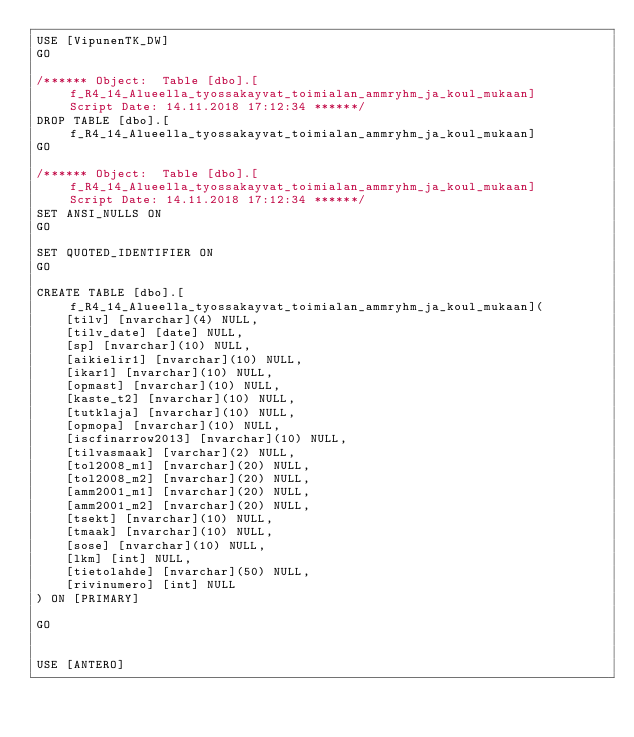<code> <loc_0><loc_0><loc_500><loc_500><_SQL_>USE [VipunenTK_DW]
GO

/****** Object:  Table [dbo].[f_R4_14_Alueella_tyossakayvat_toimialan_ammryhm_ja_koul_mukaan]    Script Date: 14.11.2018 17:12:34 ******/
DROP TABLE [dbo].[f_R4_14_Alueella_tyossakayvat_toimialan_ammryhm_ja_koul_mukaan]
GO

/****** Object:  Table [dbo].[f_R4_14_Alueella_tyossakayvat_toimialan_ammryhm_ja_koul_mukaan]    Script Date: 14.11.2018 17:12:34 ******/
SET ANSI_NULLS ON
GO

SET QUOTED_IDENTIFIER ON
GO

CREATE TABLE [dbo].[f_R4_14_Alueella_tyossakayvat_toimialan_ammryhm_ja_koul_mukaan](
	[tilv] [nvarchar](4) NULL,
	[tilv_date] [date] NULL,
	[sp] [nvarchar](10) NULL,
	[aikielir1] [nvarchar](10) NULL,
	[ikar1] [nvarchar](10) NULL,
	[opmast] [nvarchar](10) NULL,
	[kaste_t2] [nvarchar](10) NULL,
	[tutklaja] [nvarchar](10) NULL,
	[opmopa] [nvarchar](10) NULL,
	[iscfinarrow2013] [nvarchar](10) NULL,
	[tilvasmaak] [varchar](2) NULL,
	[tol2008_m1] [nvarchar](20) NULL,
	[tol2008_m2] [nvarchar](20) NULL,
	[amm2001_m1] [nvarchar](20) NULL,
	[amm2001_m2] [nvarchar](20) NULL,
	[tsekt] [nvarchar](10) NULL,
	[tmaak] [nvarchar](10) NULL,
	[sose] [nvarchar](10) NULL,
	[lkm] [int] NULL,
	[tietolahde] [nvarchar](50) NULL,
	[rivinumero] [int] NULL
) ON [PRIMARY]

GO


USE [ANTERO]</code> 